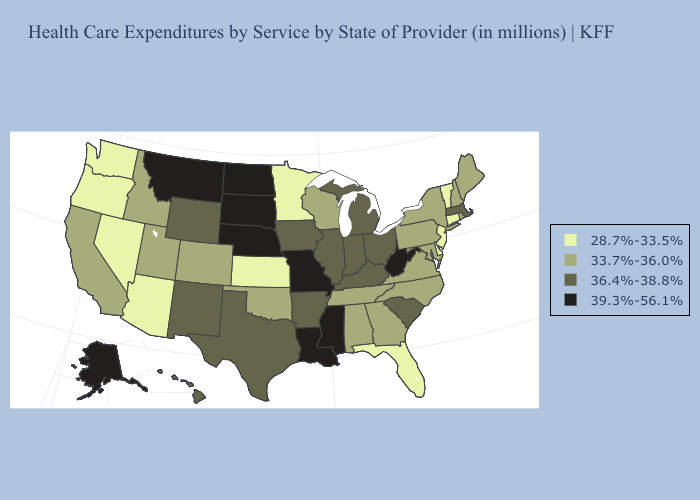Does New Hampshire have the same value as Utah?
Quick response, please. Yes. What is the lowest value in the USA?
Short answer required. 28.7%-33.5%. What is the highest value in states that border Missouri?
Quick response, please. 39.3%-56.1%. Does New York have the lowest value in the USA?
Write a very short answer. No. Among the states that border South Dakota , does Nebraska have the lowest value?
Concise answer only. No. What is the value of Georgia?
Write a very short answer. 33.7%-36.0%. What is the value of California?
Short answer required. 33.7%-36.0%. Among the states that border Colorado , which have the highest value?
Give a very brief answer. Nebraska. Name the states that have a value in the range 36.4%-38.8%?
Short answer required. Arkansas, Hawaii, Illinois, Indiana, Iowa, Kentucky, Massachusetts, Michigan, New Mexico, Ohio, South Carolina, Texas, Wyoming. Does Indiana have the highest value in the USA?
Write a very short answer. No. What is the lowest value in the USA?
Give a very brief answer. 28.7%-33.5%. What is the value of New Jersey?
Answer briefly. 28.7%-33.5%. Among the states that border Alabama , does Florida have the highest value?
Keep it brief. No. Does New Jersey have the lowest value in the Northeast?
Concise answer only. Yes. What is the lowest value in the USA?
Answer briefly. 28.7%-33.5%. 